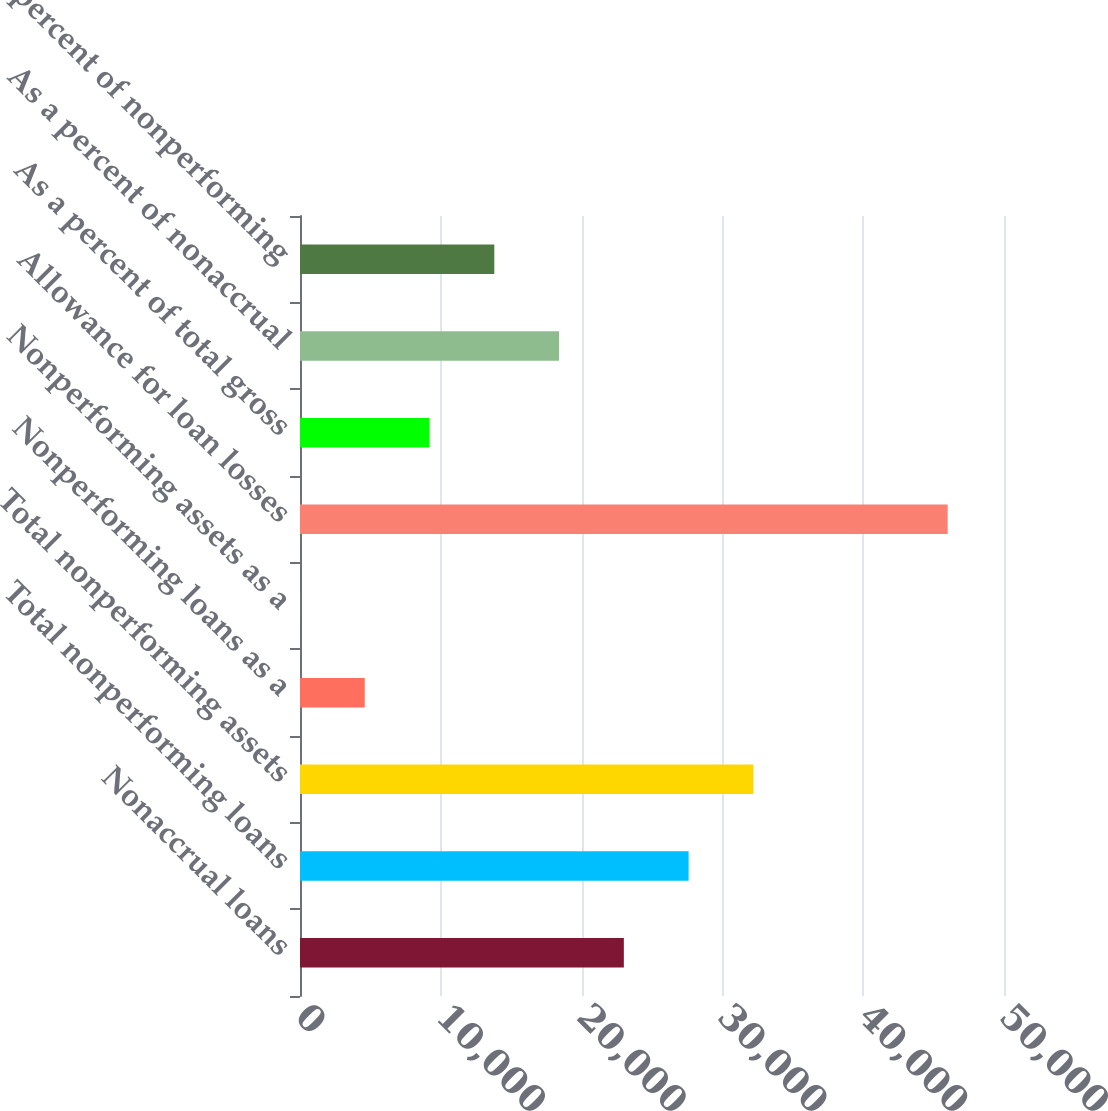Convert chart to OTSL. <chart><loc_0><loc_0><loc_500><loc_500><bar_chart><fcel>Nonaccrual loans<fcel>Total nonperforming loans<fcel>Total nonperforming assets<fcel>Nonperforming loans as a<fcel>Nonperforming assets as a<fcel>Allowance for loan losses<fcel>As a percent of total gross<fcel>As a percent of nonaccrual<fcel>As a percent of nonperforming<nl><fcel>23000.3<fcel>27600.2<fcel>32200.2<fcel>4600.54<fcel>0.6<fcel>46000<fcel>9200.48<fcel>18400.4<fcel>13800.4<nl></chart> 